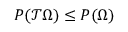Convert formula to latex. <formula><loc_0><loc_0><loc_500><loc_500>P ( \mathcal { T } \Omega ) \leq P ( \Omega )</formula> 